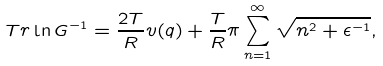<formula> <loc_0><loc_0><loc_500><loc_500>T r \ln G ^ { - 1 } = \frac { 2 T } { R } v ( q ) + \frac { T } { R } \pi \sum _ { n = 1 } ^ { \infty } \sqrt { n ^ { 2 } + \epsilon ^ { - 1 } } ,</formula> 